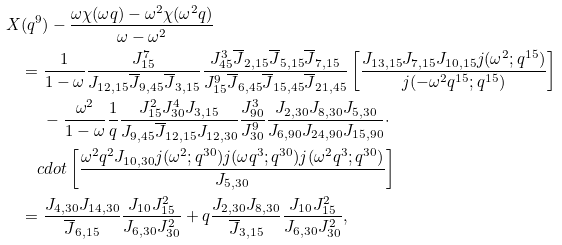<formula> <loc_0><loc_0><loc_500><loc_500>X & ( q ^ { 9 } ) - \frac { \omega \chi ( \omega q ) - \omega ^ { 2 } \chi ( \omega ^ { 2 } q ) } { \omega - \omega ^ { 2 } } \\ & = \frac { 1 } { 1 - \omega } \frac { J _ { 1 5 } ^ { 7 } } { J _ { 1 2 , 1 5 } \overline { J } _ { 9 , 4 5 } \overline { J } _ { 3 , 1 5 } } \frac { J _ { 4 5 } ^ { 3 } \overline { J } _ { 2 , 1 5 } \overline { J } _ { 5 , 1 5 } \overline { J } _ { 7 , 1 5 } } { J _ { 1 5 } ^ { 9 } \overline { J } _ { 6 , 4 5 } \overline { J } _ { 1 5 , 4 5 } \overline { J } _ { 2 1 , 4 5 } } \left [ \frac { J _ { 1 3 , 1 5 } J _ { 7 , 1 5 } J _ { 1 0 , 1 5 } j ( \omega ^ { 2 } ; q ^ { 1 5 } ) } { j ( - \omega ^ { 2 } q ^ { 1 5 } ; q ^ { 1 5 } ) } \right ] \\ & \quad \ - \frac { \omega ^ { 2 } } { 1 - \omega } \frac { 1 } { q } \frac { J _ { 1 5 } ^ { 2 } J _ { 3 0 } ^ { 4 } J _ { 3 , 1 5 } } { J _ { 9 , 4 5 } \overline { J } _ { 1 2 , 1 5 } J _ { 1 2 , 3 0 } } \frac { J _ { 9 0 } ^ { 3 } } { J _ { 3 0 } ^ { 9 } } \frac { J _ { 2 , 3 0 } J _ { 8 , 3 0 } J _ { 5 , 3 0 } } { J _ { 6 , 9 0 } J _ { 2 4 , 9 0 } J _ { 1 5 , 9 0 } } \cdot \\ & \quad c d o t \left [ \frac { \omega ^ { 2 } q ^ { 2 } J _ { 1 0 , 3 0 } j ( \omega ^ { 2 } ; q ^ { 3 0 } ) j ( \omega q ^ { 3 } ; q ^ { 3 0 } ) j ( \omega ^ { 2 } q ^ { 3 } ; q ^ { 3 0 } ) } { J _ { 5 , 3 0 } } \right ] \\ & = \frac { J _ { 4 , 3 0 } J _ { 1 4 , 3 0 } } { \overline { J } _ { 6 , 1 5 } } \frac { J _ { 1 0 } J _ { 1 5 } ^ { 2 } } { J _ { 6 , 3 0 } J _ { 3 0 } ^ { 2 } } + q \frac { J _ { 2 , 3 0 } J _ { 8 , 3 0 } } { \overline { J } _ { 3 , 1 5 } } \frac { J _ { 1 0 } J _ { 1 5 } ^ { 2 } } { J _ { 6 , 3 0 } J _ { 3 0 } ^ { 2 } } ,</formula> 